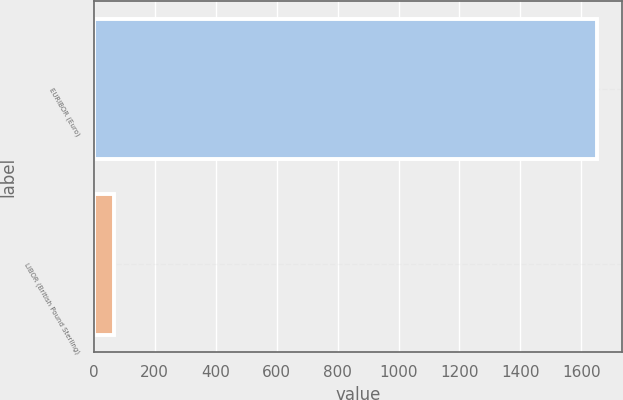Convert chart. <chart><loc_0><loc_0><loc_500><loc_500><bar_chart><fcel>EURIBOR (Euro)<fcel>LIBOR (British Pound Sterling)<nl><fcel>1651<fcel>68<nl></chart> 